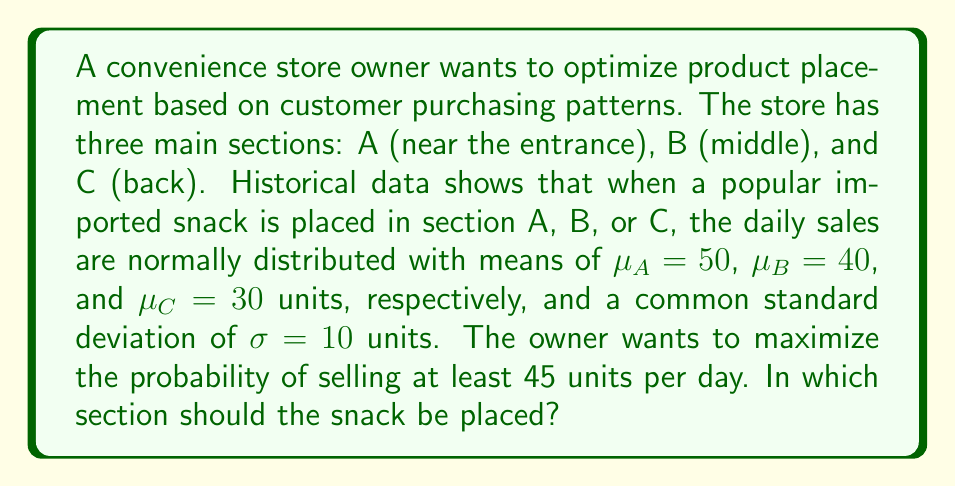Teach me how to tackle this problem. To solve this problem, we need to calculate the probability of selling at least 45 units for each section and compare them. We'll use the standard normal distribution (z-score) to find these probabilities.

1. For section A:
   $z_A = \frac{45 - \mu_A}{\sigma} = \frac{45 - 50}{10} = -0.5$
   $P(X_A \geq 45) = 1 - P(X_A < 45) = 1 - \Phi(-0.5) \approx 0.6915$

2. For section B:
   $z_B = \frac{45 - \mu_B}{\sigma} = \frac{45 - 40}{10} = 0.5$
   $P(X_B \geq 45) = 1 - P(X_B < 45) = 1 - \Phi(0.5) \approx 0.3085$

3. For section C:
   $z_C = \frac{45 - \mu_C}{\sigma} = \frac{45 - 30}{10} = 1.5$
   $P(X_C \geq 45) = 1 - P(X_C < 45) = 1 - \Phi(1.5) \approx 0.0668$

Where $\Phi(z)$ is the cumulative distribution function of the standard normal distribution.

Comparing the probabilities:
$P(X_A \geq 45) > P(X_B \geq 45) > P(X_C \geq 45)$

Therefore, placing the snack in section A (near the entrance) maximizes the probability of selling at least 45 units per day.
Answer: The snack should be placed in section A (near the entrance) to maximize the probability of selling at least 45 units per day. 